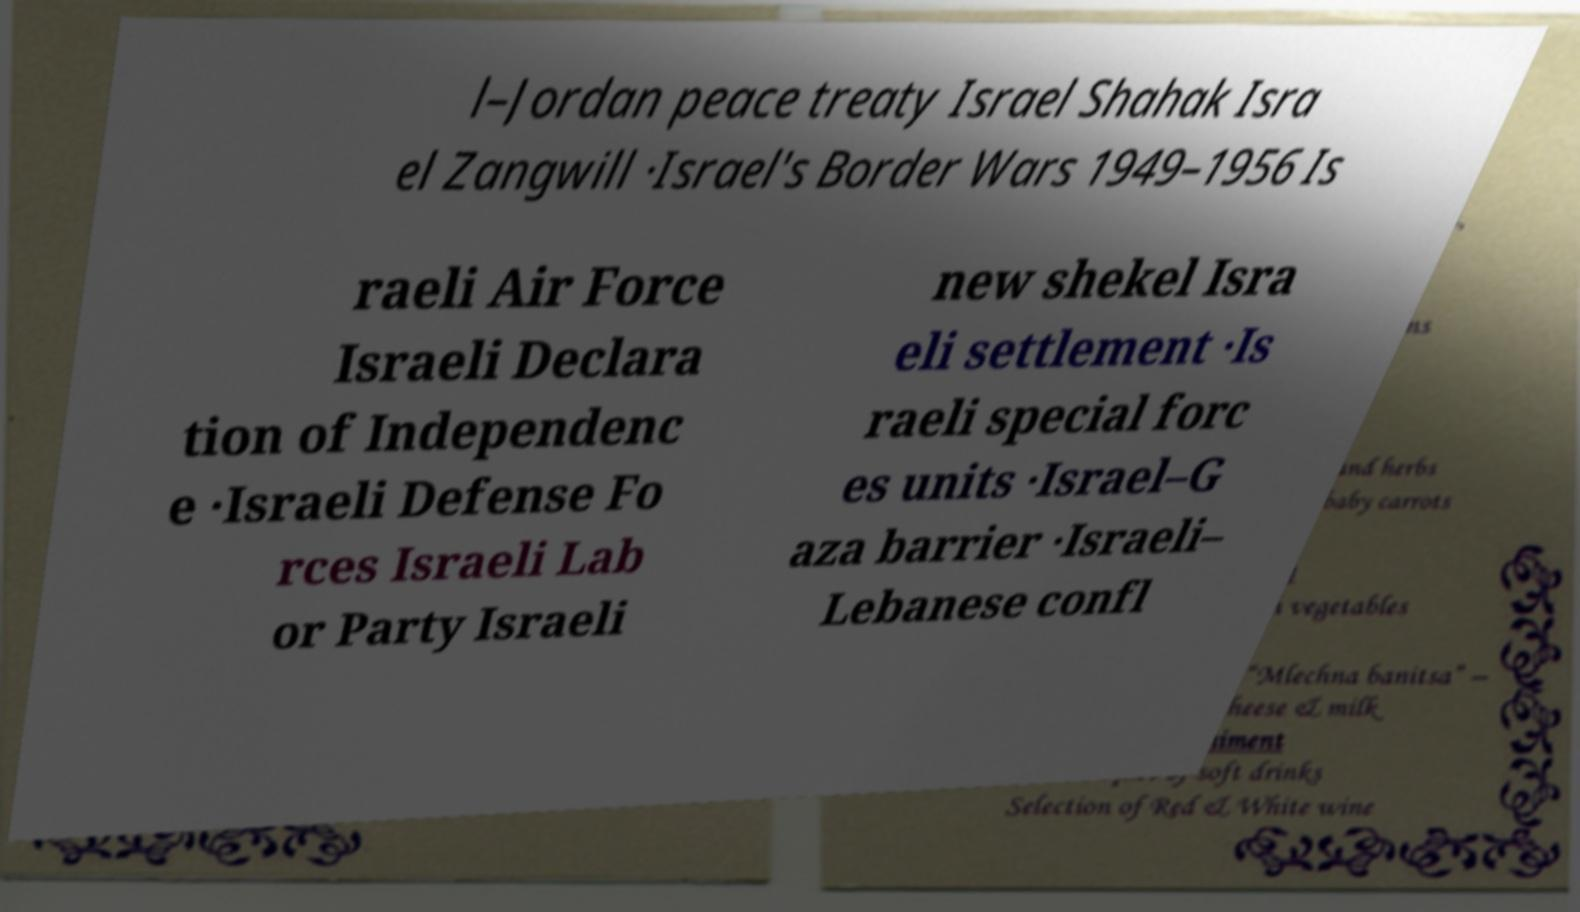Could you assist in decoding the text presented in this image and type it out clearly? l–Jordan peace treaty Israel Shahak Isra el Zangwill ·Israel's Border Wars 1949–1956 Is raeli Air Force Israeli Declara tion of Independenc e ·Israeli Defense Fo rces Israeli Lab or Party Israeli new shekel Isra eli settlement ·Is raeli special forc es units ·Israel–G aza barrier ·Israeli– Lebanese confl 